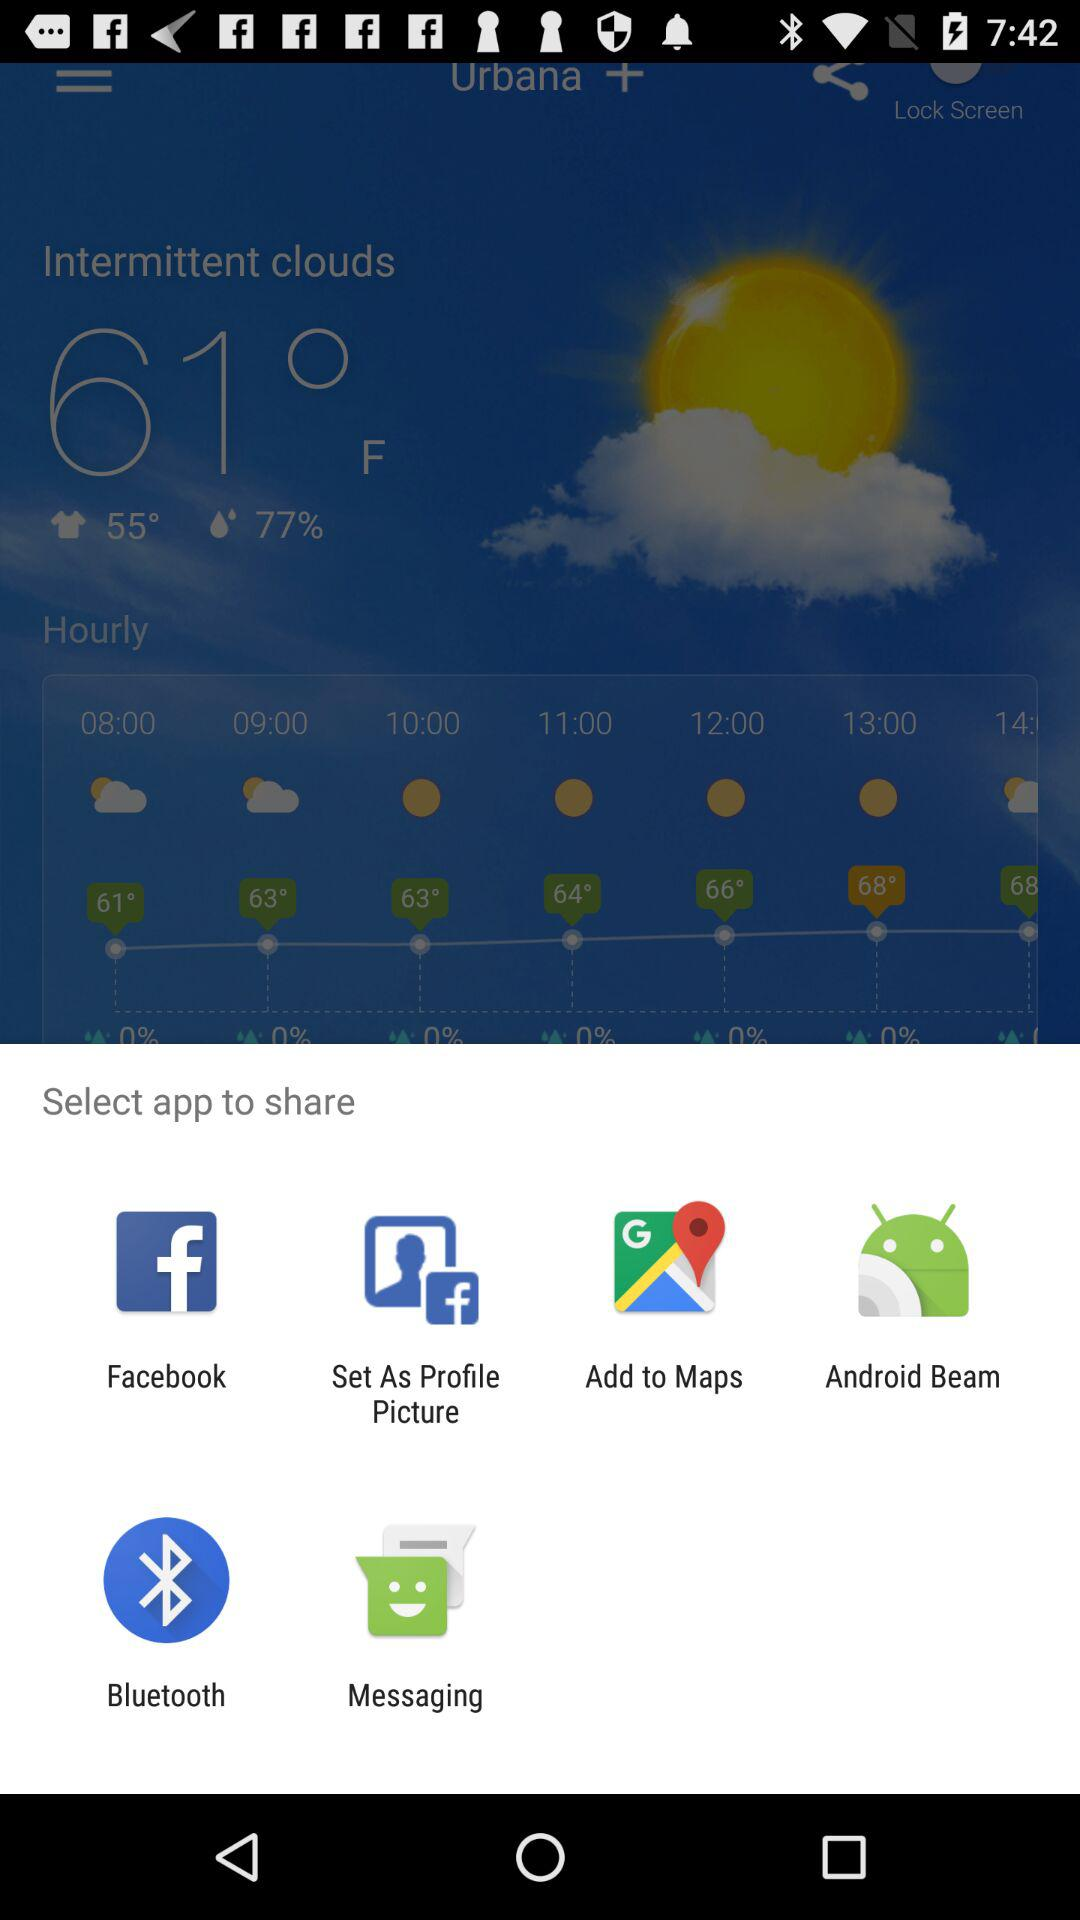What are the sharing options available? The available sharing options are "Facebook", "Set As Profile Picture", "Add to Maps", "Android Beam", "Bluetooth" and "Messaging". 